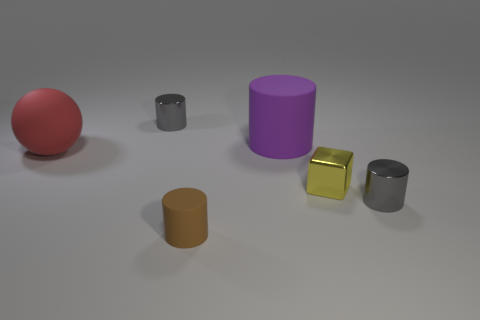Add 2 big cyan metal cylinders. How many objects exist? 8 Subtract all cubes. How many objects are left? 5 Add 6 big balls. How many big balls are left? 7 Add 2 matte cylinders. How many matte cylinders exist? 4 Subtract 0 blue balls. How many objects are left? 6 Subtract all yellow things. Subtract all large purple rubber things. How many objects are left? 4 